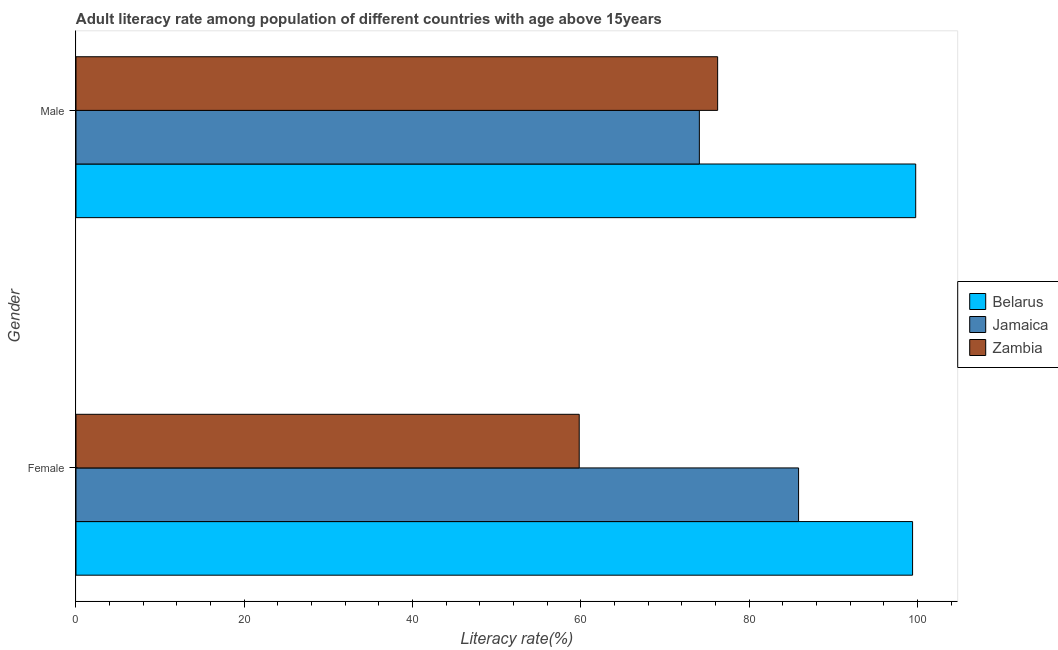How many different coloured bars are there?
Offer a very short reply. 3. How many groups of bars are there?
Keep it short and to the point. 2. Are the number of bars per tick equal to the number of legend labels?
Your response must be concise. Yes. What is the female adult literacy rate in Belarus?
Your answer should be compact. 99.42. Across all countries, what is the maximum male adult literacy rate?
Provide a short and direct response. 99.79. Across all countries, what is the minimum female adult literacy rate?
Provide a succinct answer. 59.8. In which country was the female adult literacy rate maximum?
Provide a short and direct response. Belarus. In which country was the male adult literacy rate minimum?
Make the answer very short. Jamaica. What is the total female adult literacy rate in the graph?
Your response must be concise. 245.09. What is the difference between the female adult literacy rate in Zambia and that in Jamaica?
Your answer should be compact. -26.07. What is the difference between the female adult literacy rate in Zambia and the male adult literacy rate in Belarus?
Your response must be concise. -39.99. What is the average male adult literacy rate per country?
Provide a short and direct response. 83.38. What is the difference between the female adult literacy rate and male adult literacy rate in Belarus?
Your answer should be very brief. -0.37. What is the ratio of the female adult literacy rate in Belarus to that in Jamaica?
Your answer should be very brief. 1.16. What does the 3rd bar from the top in Male represents?
Ensure brevity in your answer.  Belarus. What does the 2nd bar from the bottom in Male represents?
Offer a terse response. Jamaica. How many bars are there?
Offer a very short reply. 6. How many countries are there in the graph?
Ensure brevity in your answer.  3. Are the values on the major ticks of X-axis written in scientific E-notation?
Keep it short and to the point. No. Does the graph contain grids?
Make the answer very short. No. How many legend labels are there?
Offer a terse response. 3. What is the title of the graph?
Give a very brief answer. Adult literacy rate among population of different countries with age above 15years. What is the label or title of the X-axis?
Offer a terse response. Literacy rate(%). What is the label or title of the Y-axis?
Keep it short and to the point. Gender. What is the Literacy rate(%) of Belarus in Female?
Offer a terse response. 99.42. What is the Literacy rate(%) of Jamaica in Female?
Your answer should be very brief. 85.87. What is the Literacy rate(%) of Zambia in Female?
Make the answer very short. 59.8. What is the Literacy rate(%) of Belarus in Male?
Your answer should be compact. 99.79. What is the Literacy rate(%) of Jamaica in Male?
Make the answer very short. 74.08. What is the Literacy rate(%) of Zambia in Male?
Your answer should be compact. 76.25. Across all Gender, what is the maximum Literacy rate(%) of Belarus?
Provide a short and direct response. 99.79. Across all Gender, what is the maximum Literacy rate(%) of Jamaica?
Keep it short and to the point. 85.87. Across all Gender, what is the maximum Literacy rate(%) of Zambia?
Your response must be concise. 76.25. Across all Gender, what is the minimum Literacy rate(%) of Belarus?
Give a very brief answer. 99.42. Across all Gender, what is the minimum Literacy rate(%) in Jamaica?
Give a very brief answer. 74.08. Across all Gender, what is the minimum Literacy rate(%) of Zambia?
Offer a terse response. 59.8. What is the total Literacy rate(%) of Belarus in the graph?
Offer a very short reply. 199.21. What is the total Literacy rate(%) of Jamaica in the graph?
Ensure brevity in your answer.  159.95. What is the total Literacy rate(%) of Zambia in the graph?
Offer a terse response. 136.06. What is the difference between the Literacy rate(%) of Belarus in Female and that in Male?
Make the answer very short. -0.37. What is the difference between the Literacy rate(%) of Jamaica in Female and that in Male?
Give a very brief answer. 11.79. What is the difference between the Literacy rate(%) of Zambia in Female and that in Male?
Provide a succinct answer. -16.45. What is the difference between the Literacy rate(%) in Belarus in Female and the Literacy rate(%) in Jamaica in Male?
Offer a terse response. 25.34. What is the difference between the Literacy rate(%) in Belarus in Female and the Literacy rate(%) in Zambia in Male?
Offer a very short reply. 23.17. What is the difference between the Literacy rate(%) of Jamaica in Female and the Literacy rate(%) of Zambia in Male?
Offer a very short reply. 9.62. What is the average Literacy rate(%) of Belarus per Gender?
Your answer should be compact. 99.61. What is the average Literacy rate(%) of Jamaica per Gender?
Your response must be concise. 79.98. What is the average Literacy rate(%) of Zambia per Gender?
Keep it short and to the point. 68.03. What is the difference between the Literacy rate(%) in Belarus and Literacy rate(%) in Jamaica in Female?
Make the answer very short. 13.55. What is the difference between the Literacy rate(%) in Belarus and Literacy rate(%) in Zambia in Female?
Give a very brief answer. 39.62. What is the difference between the Literacy rate(%) in Jamaica and Literacy rate(%) in Zambia in Female?
Your response must be concise. 26.07. What is the difference between the Literacy rate(%) in Belarus and Literacy rate(%) in Jamaica in Male?
Make the answer very short. 25.71. What is the difference between the Literacy rate(%) of Belarus and Literacy rate(%) of Zambia in Male?
Offer a very short reply. 23.54. What is the difference between the Literacy rate(%) in Jamaica and Literacy rate(%) in Zambia in Male?
Make the answer very short. -2.17. What is the ratio of the Literacy rate(%) in Belarus in Female to that in Male?
Provide a short and direct response. 1. What is the ratio of the Literacy rate(%) of Jamaica in Female to that in Male?
Offer a very short reply. 1.16. What is the ratio of the Literacy rate(%) of Zambia in Female to that in Male?
Provide a short and direct response. 0.78. What is the difference between the highest and the second highest Literacy rate(%) in Belarus?
Your answer should be compact. 0.37. What is the difference between the highest and the second highest Literacy rate(%) in Jamaica?
Provide a succinct answer. 11.79. What is the difference between the highest and the second highest Literacy rate(%) of Zambia?
Keep it short and to the point. 16.45. What is the difference between the highest and the lowest Literacy rate(%) of Belarus?
Offer a very short reply. 0.37. What is the difference between the highest and the lowest Literacy rate(%) of Jamaica?
Your answer should be compact. 11.79. What is the difference between the highest and the lowest Literacy rate(%) in Zambia?
Offer a very short reply. 16.45. 